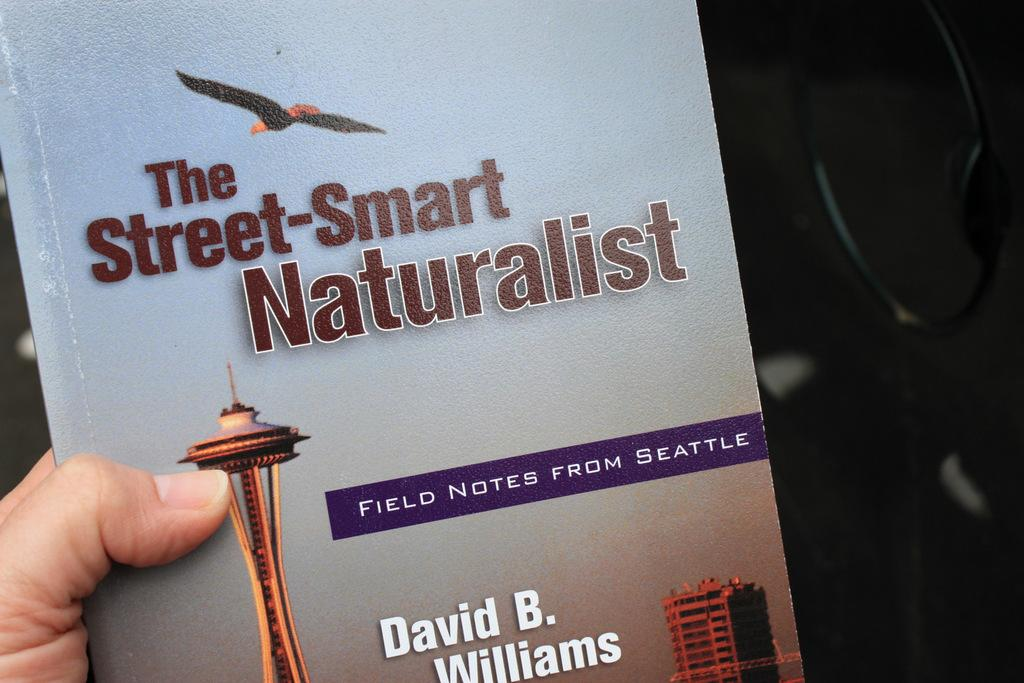Provide a one-sentence caption for the provided image. A picture of a nature book about Seattle called "The Street-Smart Naturalist" by David B. Williams. 